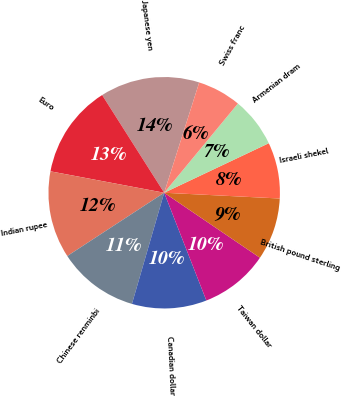<chart> <loc_0><loc_0><loc_500><loc_500><pie_chart><fcel>Japanese yen<fcel>Euro<fcel>Indian rupee<fcel>Chinese renminbi<fcel>Canadian dollar<fcel>Taiwan dollar<fcel>British pound sterling<fcel>Israeli shekel<fcel>Armenian dram<fcel>Swiss franc<nl><fcel>13.9%<fcel>13.03%<fcel>12.17%<fcel>11.3%<fcel>10.43%<fcel>9.57%<fcel>8.7%<fcel>7.83%<fcel>6.97%<fcel>6.1%<nl></chart> 